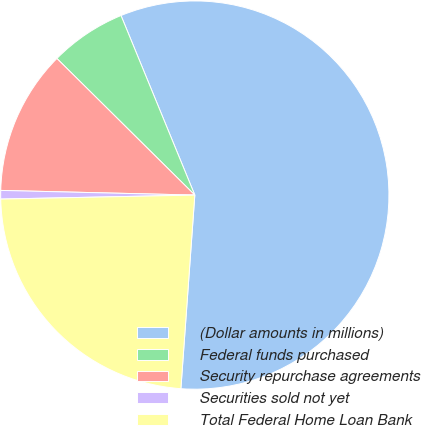Convert chart. <chart><loc_0><loc_0><loc_500><loc_500><pie_chart><fcel>(Dollar amounts in millions)<fcel>Federal funds purchased<fcel>Security repurchase agreements<fcel>Securities sold not yet<fcel>Total Federal Home Loan Bank<nl><fcel>57.35%<fcel>6.37%<fcel>12.04%<fcel>0.71%<fcel>23.53%<nl></chart> 